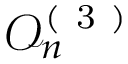Convert formula to latex. <formula><loc_0><loc_0><loc_500><loc_500>\mathcal { O } _ { n } ^ { ( 3 ) }</formula> 